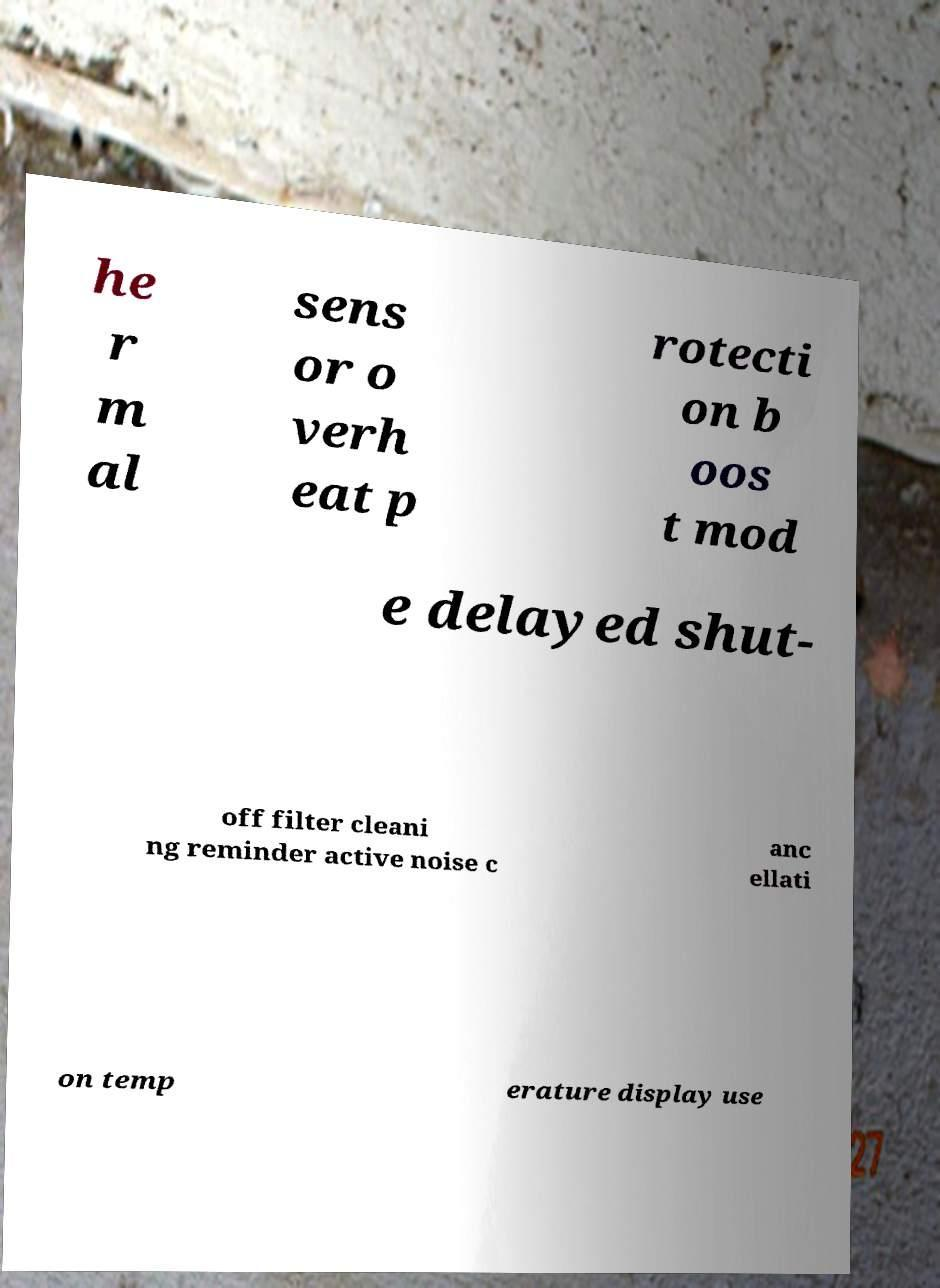For documentation purposes, I need the text within this image transcribed. Could you provide that? he r m al sens or o verh eat p rotecti on b oos t mod e delayed shut- off filter cleani ng reminder active noise c anc ellati on temp erature display use 